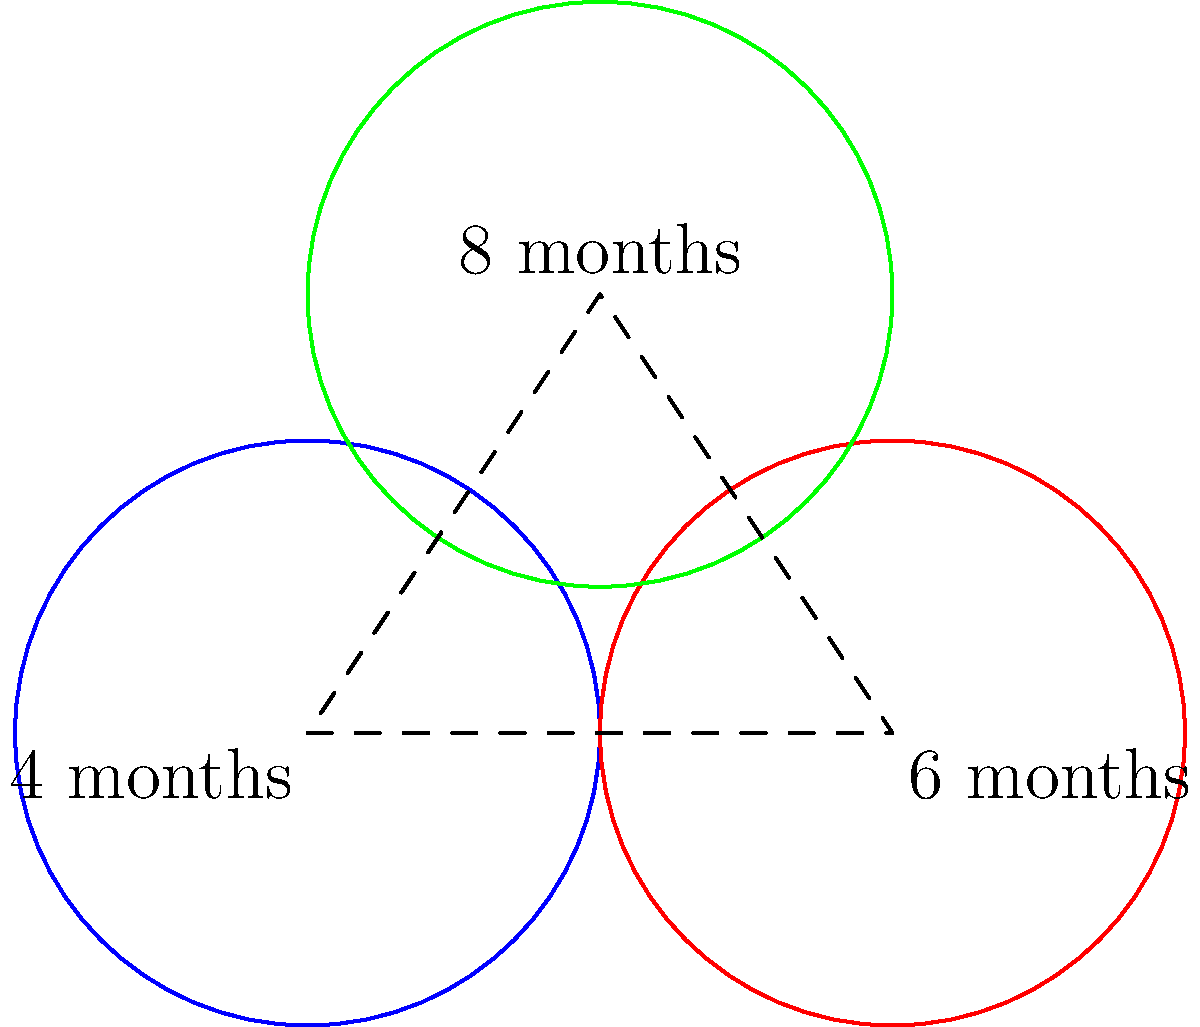In your freezer, you have three types of food with different recommended freezing times, represented by congruent circles. The centers of these circles form a triangle. If the distance between the centers of the "4 months" and "6 months" circles is 4 units, what is the area of the triangle formed by the centers of all three circles? Let's approach this step-by-step:

1) We're given three congruent circles with centers forming a triangle. The distance between two of the centers is 4 units.

2) In the diagram, we can see that the centers form a triangle. Let's call the centers A (4 months), B (6 months), and C (8 months).

3) We're told that AB = 4 units. This forms the base of our triangle.

4) The three circles are congruent, meaning they have the same radius. The line connecting their centers (AB) is a chord for the third circle centered at C.

5) This forms an equilateral triangle. In an equilateral triangle, all sides are equal and all angles are 60°.

6) To find the area of an equilateral triangle, we can use the formula:

   $$A = \frac{\sqrt{3}}{4}a^2$$

   where $a$ is the length of a side.

7) We know $a = 4$, so let's plug this into our formula:

   $$A = \frac{\sqrt{3}}{4}(4^2) = 4\sqrt{3}$$

8) Therefore, the area of the triangle is $4\sqrt{3}$ square units.
Answer: $4\sqrt{3}$ square units 